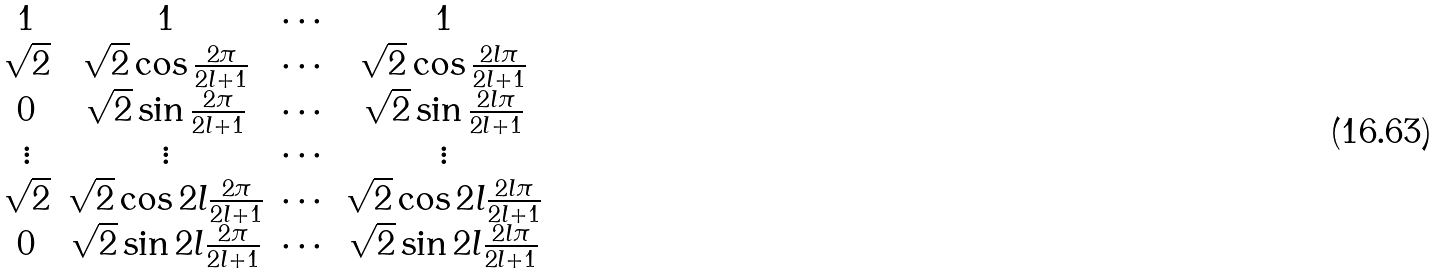Convert formula to latex. <formula><loc_0><loc_0><loc_500><loc_500>\begin{matrix} 1 & 1 & \cdots & 1 \\ \sqrt { 2 } & \sqrt { 2 } \cos \frac { 2 \pi } { 2 l + 1 } & \cdots & \sqrt { 2 } \cos \frac { 2 l \pi } { 2 l + 1 } \\ 0 & \sqrt { 2 } \sin \frac { 2 \pi } { 2 l + 1 } & \cdots & \sqrt { 2 } \sin \frac { 2 l \pi } { 2 l + 1 } \\ \vdots & \vdots & \cdots & \vdots \\ \sqrt { 2 } & \sqrt { 2 } \cos 2 l \frac { 2 \pi } { 2 l + 1 } & \cdots & \sqrt { 2 } \cos 2 l \frac { 2 l \pi } { 2 l + 1 } \\ 0 & \sqrt { 2 } \sin 2 l \frac { 2 \pi } { 2 l + 1 } & \cdots & \sqrt { 2 } \sin 2 l \frac { 2 l \pi } { 2 l + 1 } \end{matrix}</formula> 